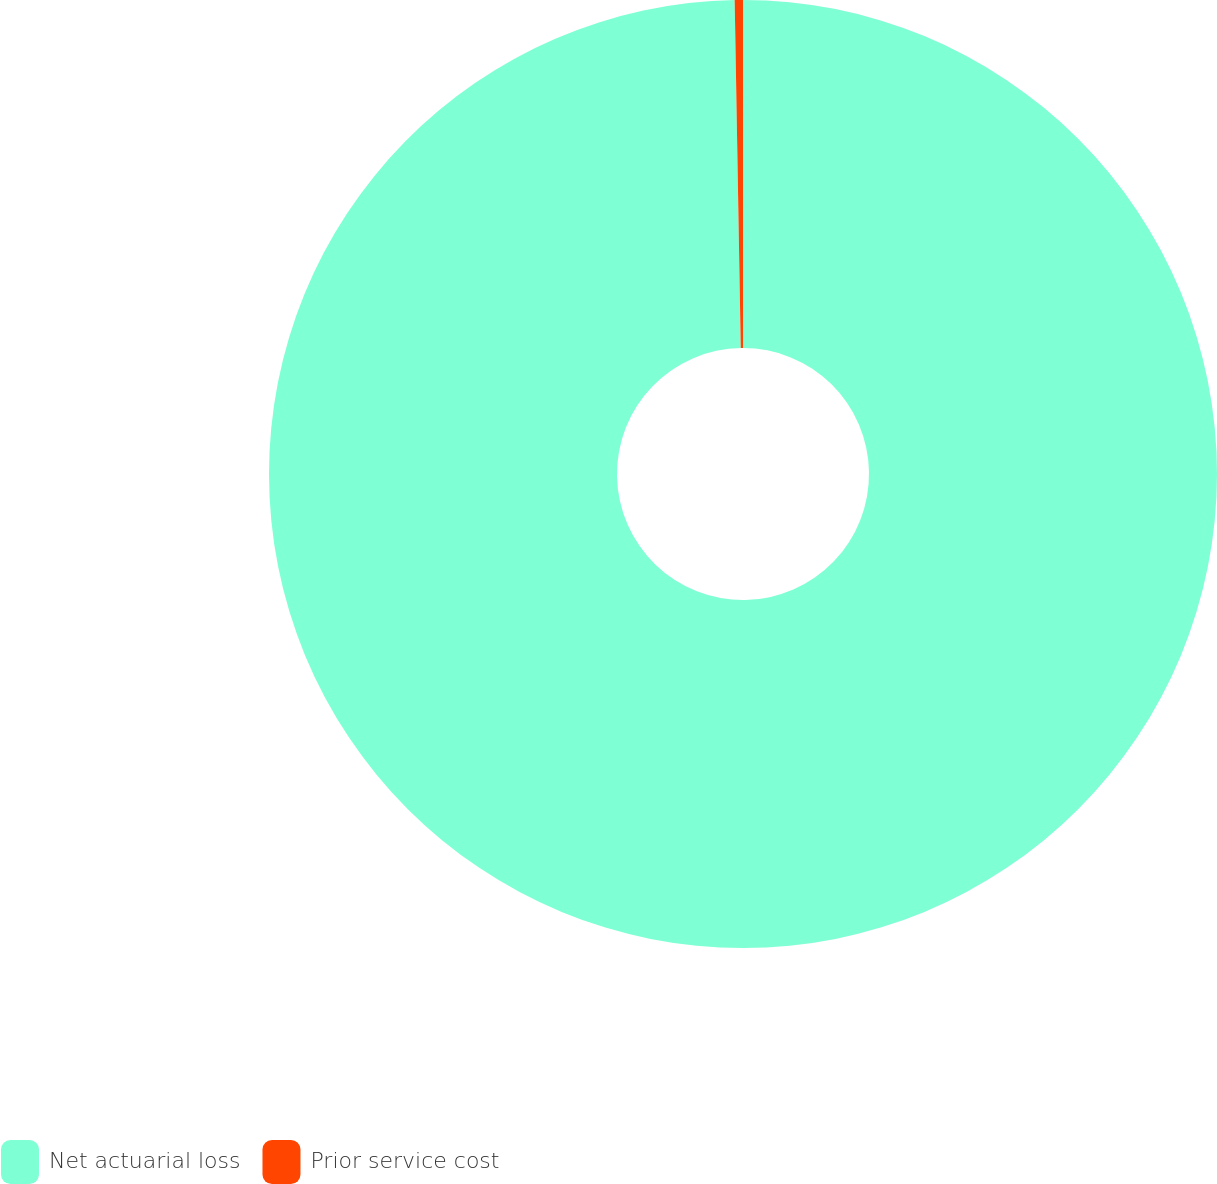<chart> <loc_0><loc_0><loc_500><loc_500><pie_chart><fcel>Net actuarial loss<fcel>Prior service cost<nl><fcel>99.72%<fcel>0.28%<nl></chart> 